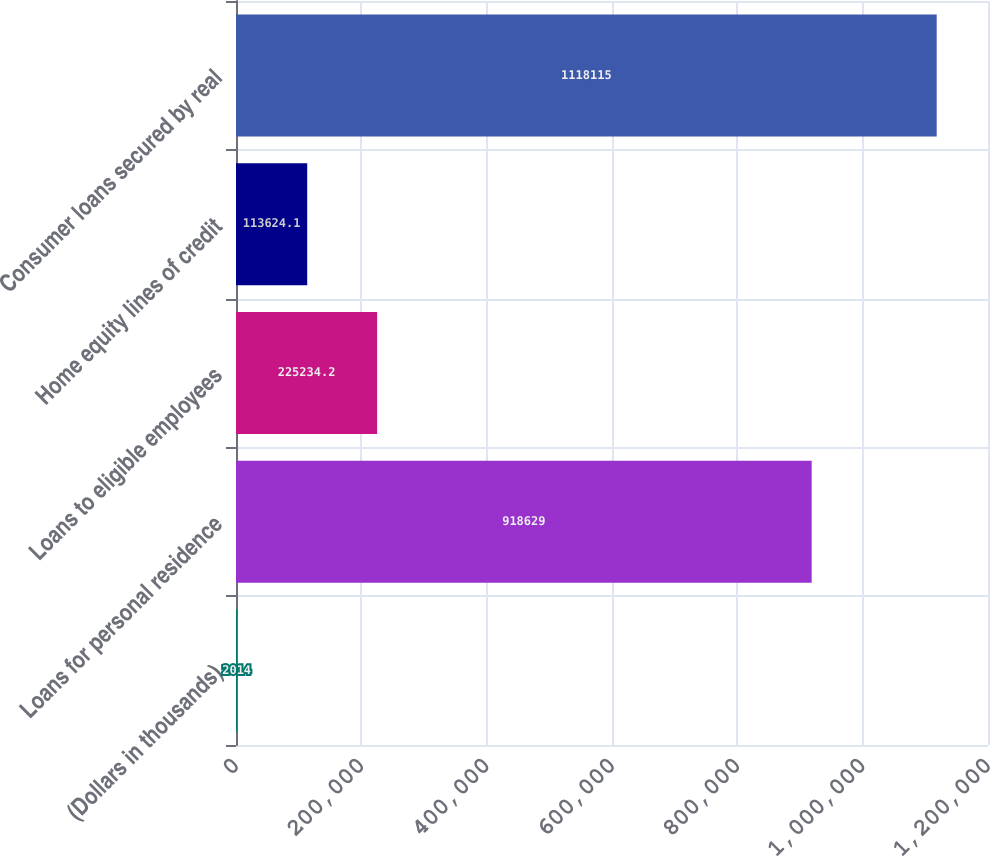Convert chart. <chart><loc_0><loc_0><loc_500><loc_500><bar_chart><fcel>(Dollars in thousands)<fcel>Loans for personal residence<fcel>Loans to eligible employees<fcel>Home equity lines of credit<fcel>Consumer loans secured by real<nl><fcel>2014<fcel>918629<fcel>225234<fcel>113624<fcel>1.11812e+06<nl></chart> 